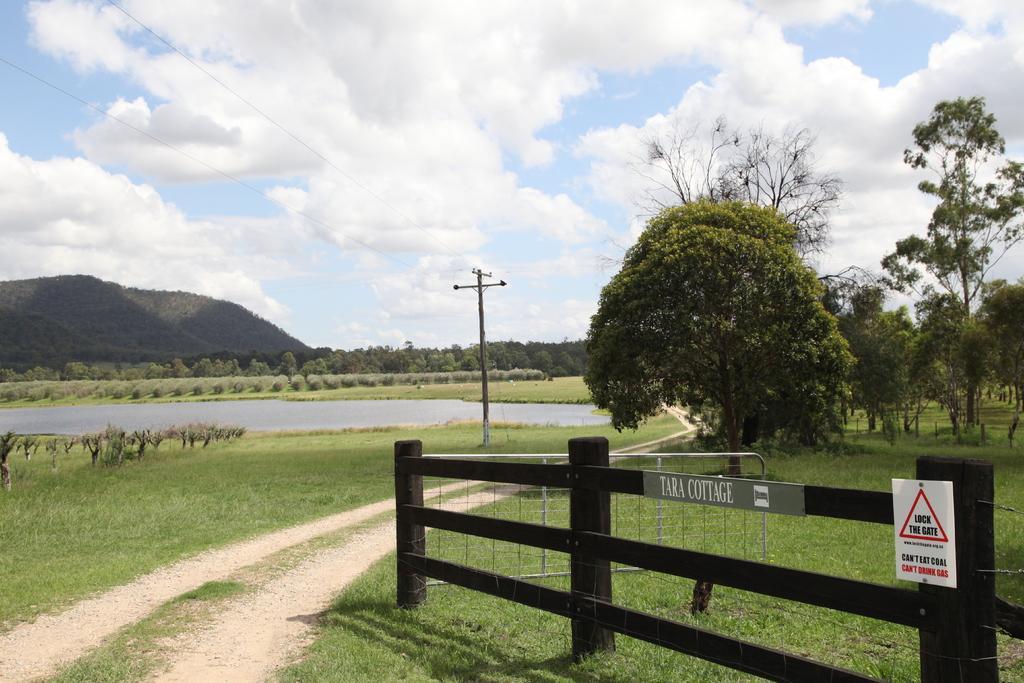Could you give a brief overview of what you see in this image? At the bottom of the image there is fencing. There is grass. In the background of the image there are trees,mountains. In the center of the image there is road. There is a electric pole. To the right side of the image there are trees. At the top of the image there is sky and clouds. 